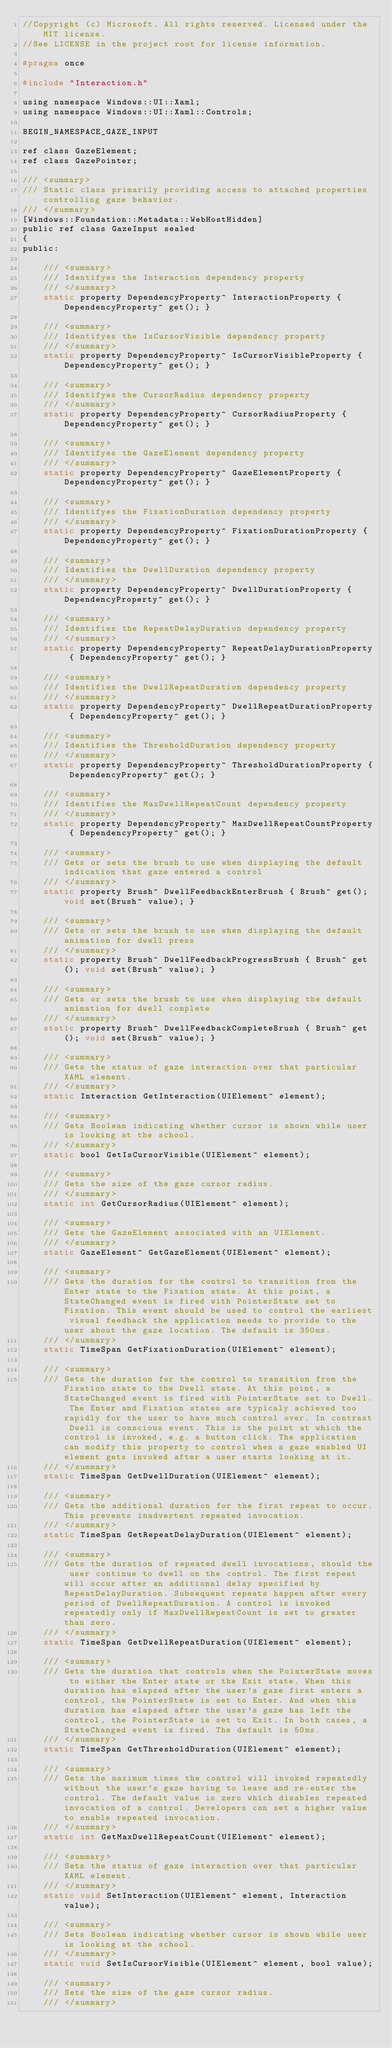Convert code to text. <code><loc_0><loc_0><loc_500><loc_500><_C_>//Copyright (c) Microsoft. All rights reserved. Licensed under the MIT license.
//See LICENSE in the project root for license information.

#pragma once

#include "Interaction.h"

using namespace Windows::UI::Xaml;
using namespace Windows::UI::Xaml::Controls;

BEGIN_NAMESPACE_GAZE_INPUT

ref class GazeElement;
ref class GazePointer;

/// <summary>
/// Static class primarily providing access to attached properties controlling gaze behavior.
/// </summary>
[Windows::Foundation::Metadata::WebHostHidden]
public ref class GazeInput sealed
{
public:

    /// <summary>
    /// Identifyes the Interaction dependency property
    /// </summary>
    static property DependencyProperty^ InteractionProperty { DependencyProperty^ get(); }

    /// <summary>
    /// Identifyes the IsCursorVisible dependency property
    /// </summary>
    static property DependencyProperty^ IsCursorVisibleProperty { DependencyProperty^ get(); }

    /// <summary>
    /// Identifyes the CursorRadius dependency property
    /// </summary>
    static property DependencyProperty^ CursorRadiusProperty { DependencyProperty^ get(); }

    /// <summary>
    /// Identifyes the GazeElement dependency property
    /// </summary>
    static property DependencyProperty^ GazeElementProperty { DependencyProperty^ get(); }

    /// <summary>
    /// Identifyes the FixationDuration dependency property
    /// </summary>
    static property DependencyProperty^ FixationDurationProperty { DependencyProperty^ get(); }

    /// <summary>
    /// Identifies the DwellDuration dependency property
    /// </summary>
    static property DependencyProperty^ DwellDurationProperty { DependencyProperty^ get(); }

    /// <summary>
    /// Identifies the RepeatDelayDuration dependency property
    /// </summary>
    static property DependencyProperty^ RepeatDelayDurationProperty { DependencyProperty^ get(); }

    /// <summary>
    /// Identifies the DwellRepeatDuration dependency property
    /// </summary>
    static property DependencyProperty^ DwellRepeatDurationProperty { DependencyProperty^ get(); }

    /// <summary>
    /// Identifies the ThresholdDuration dependency property
    /// </summary>
    static property DependencyProperty^ ThresholdDurationProperty { DependencyProperty^ get(); }

    /// <summary>
    /// Identifies the MaxDwellRepeatCount dependency property
    /// </summary>
    static property DependencyProperty^ MaxDwellRepeatCountProperty { DependencyProperty^ get(); }

    /// <summary>
    /// Gets or sets the brush to use when displaying the default indication that gaze entered a control
    /// </summary>
    static property Brush^ DwellFeedbackEnterBrush { Brush^ get(); void set(Brush^ value); }

    /// <summary>
    /// Gets or sets the brush to use when displaying the default animation for dwell press
    /// </summary>
    static property Brush^ DwellFeedbackProgressBrush { Brush^ get(); void set(Brush^ value); }

    /// <summary>
    /// Gets or sets the brush to use when displaying the default animation for dwell complete
    /// </summary>
    static property Brush^ DwellFeedbackCompleteBrush { Brush^ get(); void set(Brush^ value); }

    /// <summary>
    /// Gets the status of gaze interaction over that particular XAML element.
    /// </summary>
    static Interaction GetInteraction(UIElement^ element);

    /// <summary>
    /// Gets Boolean indicating whether cursor is shown while user is looking at the school.
    /// </summary>
    static bool GetIsCursorVisible(UIElement^ element);

    /// <summary>
    /// Gets the size of the gaze cursor radius.
    /// </summary>
    static int GetCursorRadius(UIElement^ element);
    
    /// <summary>
    /// Gets the GazeElement associated with an UIElement.
    /// </summary>
    static GazeElement^ GetGazeElement(UIElement^ element);

    /// <summary>
    /// Gets the duration for the control to transition from the Enter state to the Fixation state. At this point, a StateChanged event is fired with PointerState set to Fixation. This event should be used to control the earliest visual feedback the application needs to provide to the user about the gaze location. The default is 350ms.
    /// </summary>
    static TimeSpan GetFixationDuration(UIElement^ element);

    /// <summary>
    /// Gets the duration for the control to transition from the Fixation state to the Dwell state. At this point, a StateChanged event is fired with PointerState set to Dwell. The Enter and Fixation states are typicaly achieved too rapidly for the user to have much control over. In contrast Dwell is conscious event. This is the point at which the control is invoked, e.g. a button click. The application can modify this property to control when a gaze enabled UI element gets invoked after a user starts looking at it.
    /// </summary>
    static TimeSpan GetDwellDuration(UIElement^ element);

    /// <summary>
    /// Gets the additional duration for the first repeat to occur.This prevents inadvertent repeated invocation.
    /// </summary>
    static TimeSpan GetRepeatDelayDuration(UIElement^ element);

    /// <summary>
    /// Gets the duration of repeated dwell invocations, should the user continue to dwell on the control. The first repeat will occur after an additional delay specified by RepeatDelayDuration. Subsequent repeats happen after every period of DwellRepeatDuration. A control is invoked repeatedly only if MaxDwellRepeatCount is set to greater than zero.
    /// </summary>
    static TimeSpan GetDwellRepeatDuration(UIElement^ element);
    
    /// <summary>
    /// Gets the duration that controls when the PointerState moves to either the Enter state or the Exit state. When this duration has elapsed after the user's gaze first enters a control, the PointerState is set to Enter. And when this duration has elapsed after the user's gaze has left the control, the PointerState is set to Exit. In both cases, a StateChanged event is fired. The default is 50ms.
    /// </summary>
    static TimeSpan GetThresholdDuration(UIElement^ element);
	
    /// <summary>
    /// Gets the maximum times the control will invoked repeatedly without the user's gaze having to leave and re-enter the control. The default value is zero which disables repeated invocation of a control. Developers can set a higher value to enable repeated invocation.
    /// </summary>
    static int GetMaxDwellRepeatCount(UIElement^ element);

    /// <summary>
    /// Sets the status of gaze interaction over that particular XAML element.
    /// </summary>
    static void SetInteraction(UIElement^ element, Interaction value);
    
    /// <summary>
    /// Sets Boolean indicating whether cursor is shown while user is looking at the school.
    /// </summary>
    static void SetIsCursorVisible(UIElement^ element, bool value);
	
    /// <summary>
    /// Sets the size of the gaze cursor radius.
    /// </summary></code> 